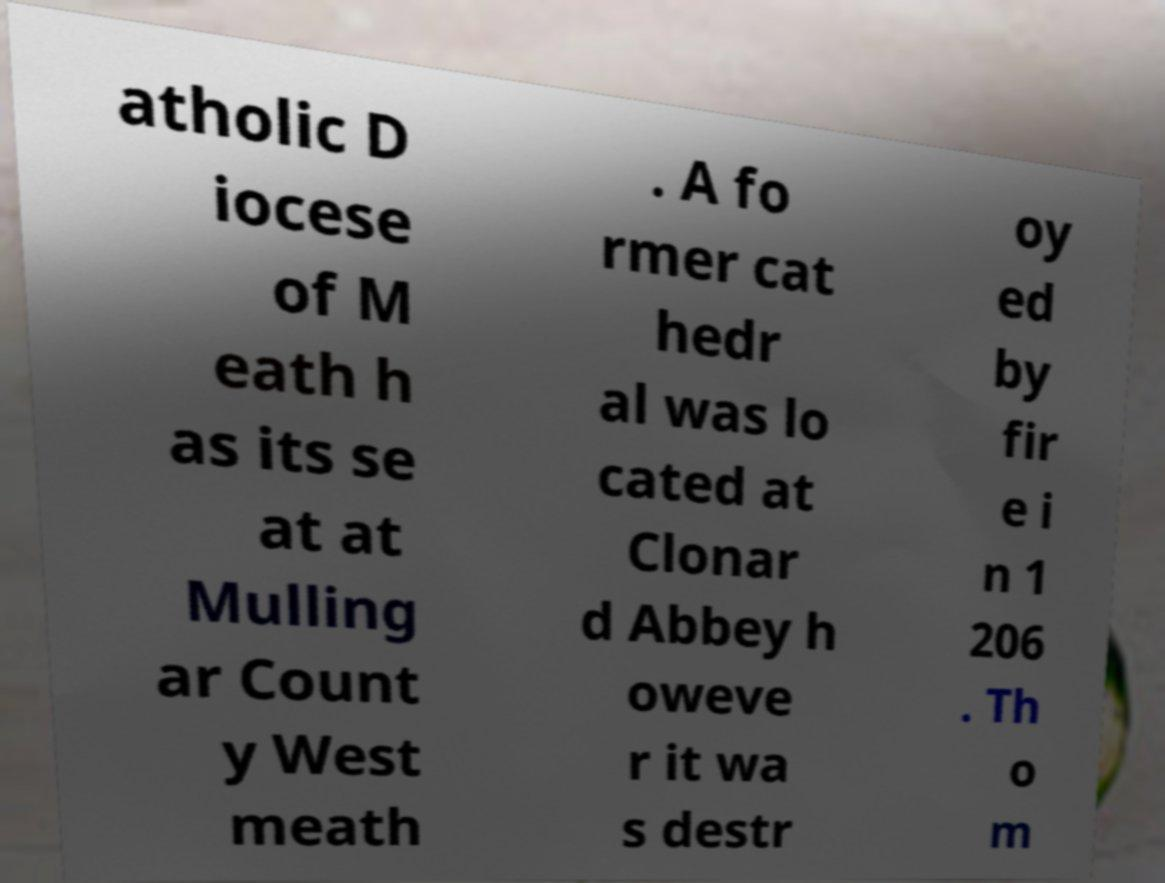I need the written content from this picture converted into text. Can you do that? atholic D iocese of M eath h as its se at at Mulling ar Count y West meath . A fo rmer cat hedr al was lo cated at Clonar d Abbey h oweve r it wa s destr oy ed by fir e i n 1 206 . Th o m 